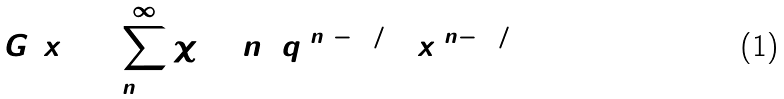Convert formula to latex. <formula><loc_0><loc_0><loc_500><loc_500>G ( x ) = \sum _ { n = 0 } ^ { \infty } { \chi } _ { 2 0 } ^ { ( 1 ) } ( n ) \, q ^ { ( n ^ { 2 } - 1 ) / 4 0 } \, x ^ { ( n - 1 ) / 2 }</formula> 